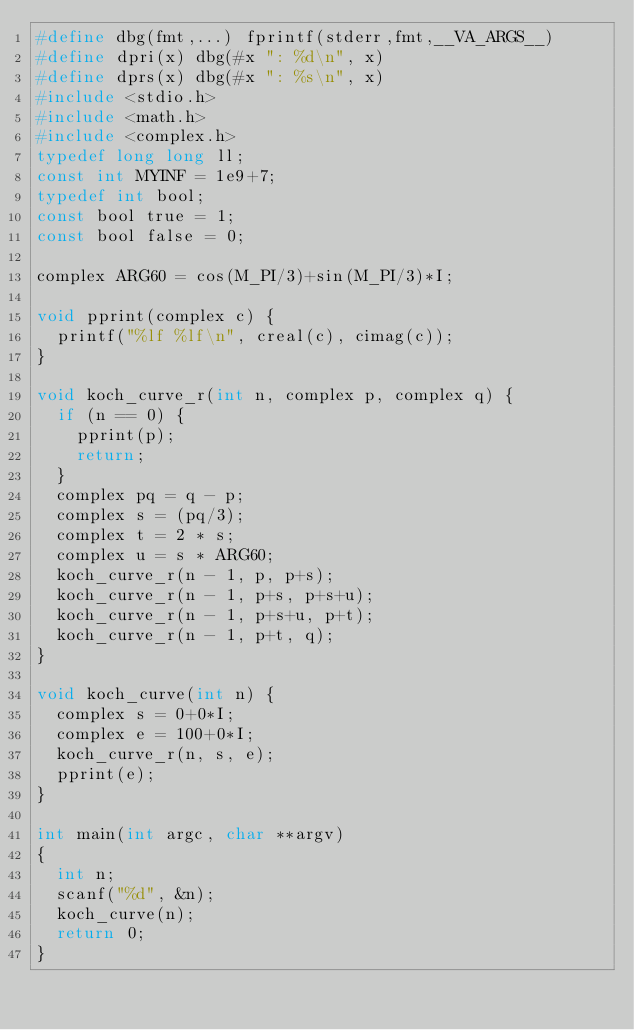Convert code to text. <code><loc_0><loc_0><loc_500><loc_500><_C_>#define dbg(fmt,...) fprintf(stderr,fmt,__VA_ARGS__)
#define dpri(x) dbg(#x ": %d\n", x)
#define dprs(x) dbg(#x ": %s\n", x)
#include <stdio.h>
#include <math.h>
#include <complex.h>
typedef long long ll;
const int MYINF = 1e9+7;
typedef int bool;
const bool true = 1;
const bool false = 0;

complex ARG60 = cos(M_PI/3)+sin(M_PI/3)*I;

void pprint(complex c) {
	printf("%lf %lf\n", creal(c), cimag(c));
}

void koch_curve_r(int n, complex p, complex q) {
	if (n == 0) {
		pprint(p);
		return;
	}
	complex pq = q - p;
	complex s = (pq/3);
	complex t = 2 * s;
	complex u = s * ARG60;
	koch_curve_r(n - 1, p, p+s);
	koch_curve_r(n - 1, p+s, p+s+u);
	koch_curve_r(n - 1, p+s+u, p+t);
	koch_curve_r(n - 1, p+t, q);
}

void koch_curve(int n) {
	complex s = 0+0*I;
	complex e = 100+0*I;
	koch_curve_r(n, s, e);
	pprint(e);
}

int main(int argc, char **argv)
{
	int n;
	scanf("%d", &n);
	koch_curve(n);
	return 0;
}</code> 